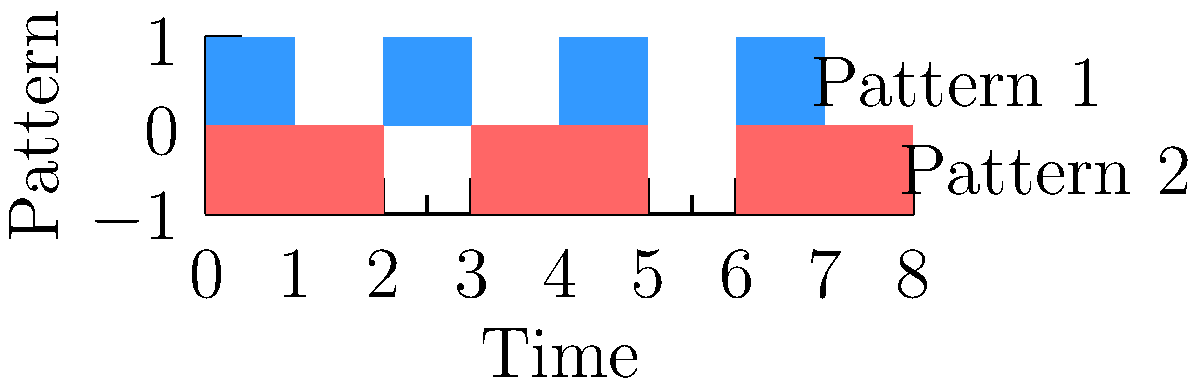In the context of analyzing rhythmic patterns in Hawaiian chants using vectors, consider the two patterns shown in the graph. If we represent each pattern as a vector, with 1 indicating a beat and 0 indicating silence, what would be the dot product of these two vectors for their overlapping portion? To solve this problem, let's follow these steps:

1. Identify the vectors:
   Pattern 1: $\vec{v_1} = [1, 0, 1, 0, 1, 0, 1, 0]$
   Pattern 2: $\vec{v_2} = [1, 1, 0, 1, 1, 0, 1, 1, 0]$

2. Find the overlapping portion:
   The overlapping portion consists of the first 8 elements of each vector.

3. Calculate the dot product for the overlapping portion:
   The dot product is defined as: $\vec{v_1} \cdot \vec{v_2} = \sum_{i=1}^n v_{1i} v_{2i}$

   Let's multiply the corresponding elements:
   $(1 \times 1) + (0 \times 1) + (1 \times 0) + (0 \times 1) + (1 \times 1) + (0 \times 0) + (1 \times 1) + (0 \times 1)$

4. Sum up the results:
   $1 + 0 + 0 + 0 + 1 + 0 + 1 + 0 = 3$

The dot product of the overlapping portions of these two rhythmic patterns is 3, which represents the number of simultaneous beats in both patterns.
Answer: 3 